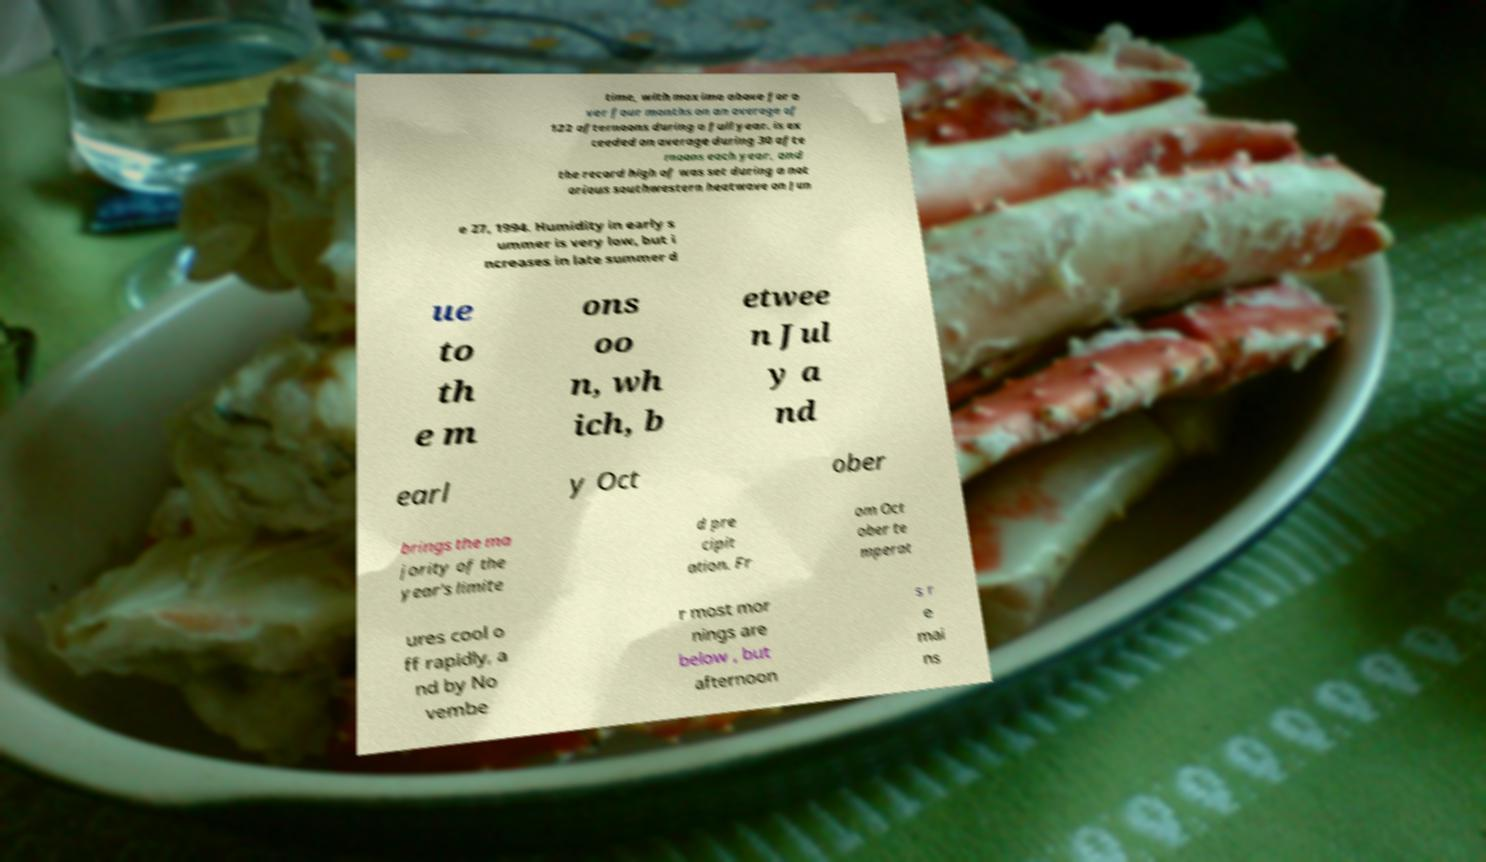Please identify and transcribe the text found in this image. time, with maxima above for o ver four months on an average of 122 afternoons during a full year. is ex ceeded on average during 30 afte rnoons each year, and the record high of was set during a not orious southwestern heatwave on Jun e 27, 1994. Humidity in early s ummer is very low, but i ncreases in late summer d ue to th e m ons oo n, wh ich, b etwee n Jul y a nd earl y Oct ober brings the ma jority of the year's limite d pre cipit ation. Fr om Oct ober te mperat ures cool o ff rapidly, a nd by No vembe r most mor nings are below , but afternoon s r e mai ns 